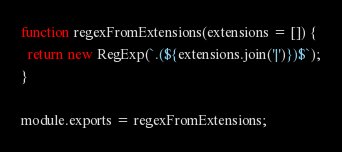Convert code to text. <code><loc_0><loc_0><loc_500><loc_500><_JavaScript_>function regexFromExtensions(extensions = []) {
  return new RegExp(`.(${extensions.join('|')})$`);
}

module.exports = regexFromExtensions;
</code> 